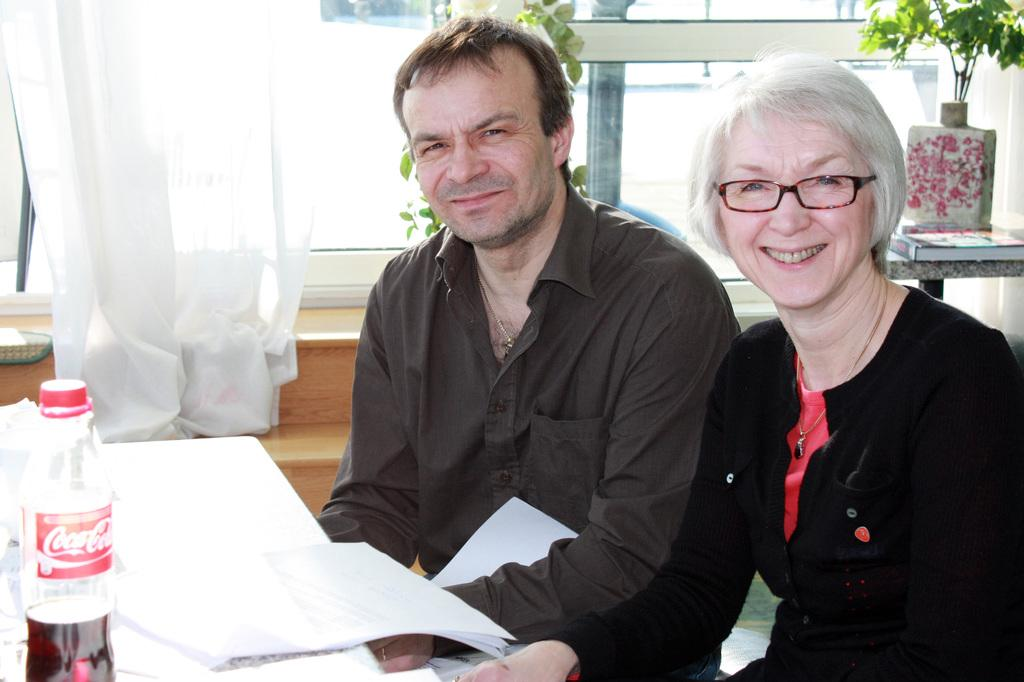How many people are sitting in the image? There are two persons sitting in the image. What objects can be seen in the image besides the people? Papers, a bottle, a glass window, a curtain, and a plant are visible in the image. What might the people be using the papers for? It is not clear from the image what the people are using the papers for, but they could be working or studying. What is the purpose of the curtain in the image? The curtain is associated with the glass window and might be used for privacy or to control the amount of light entering the room. What type of steam can be seen coming from the plant in the image? There is no steam visible in the image, and the plant does not appear to be producing steam. 